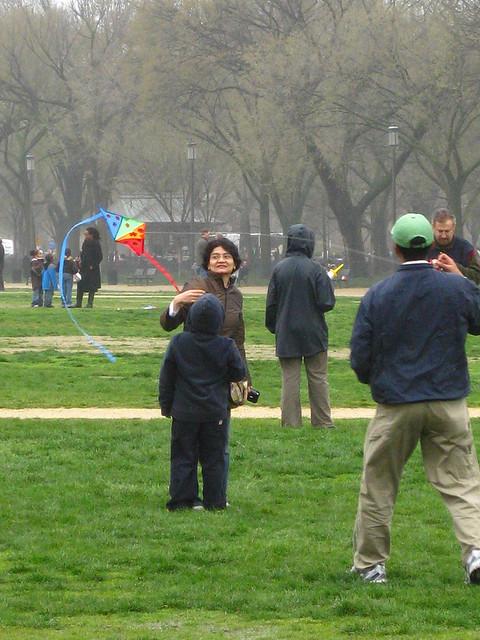What are these people doing?
Short answer required. Flying kites. What is the hooded boy holding?
Short answer required. Kite. What are they flying?
Concise answer only. Kite. Are they wearing summer clothes?
Be succinct. No. 